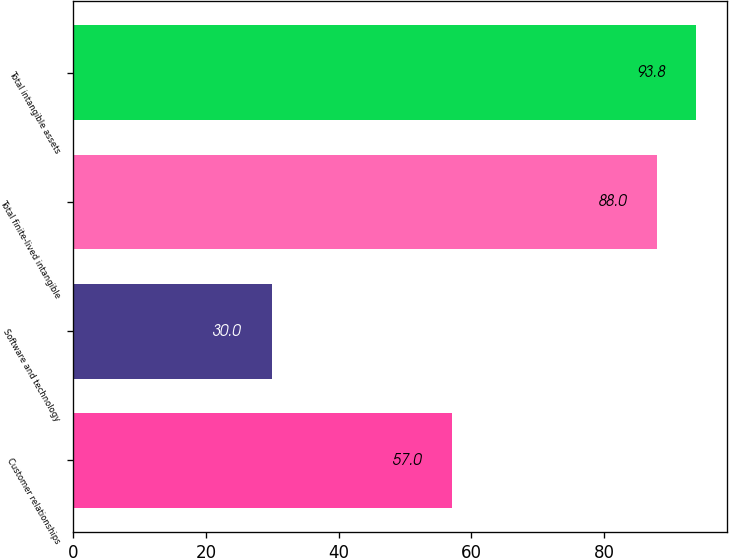Convert chart to OTSL. <chart><loc_0><loc_0><loc_500><loc_500><bar_chart><fcel>Customer relationships<fcel>Software and technology<fcel>Total finite-lived intangible<fcel>Total intangible assets<nl><fcel>57<fcel>30<fcel>88<fcel>93.8<nl></chart> 